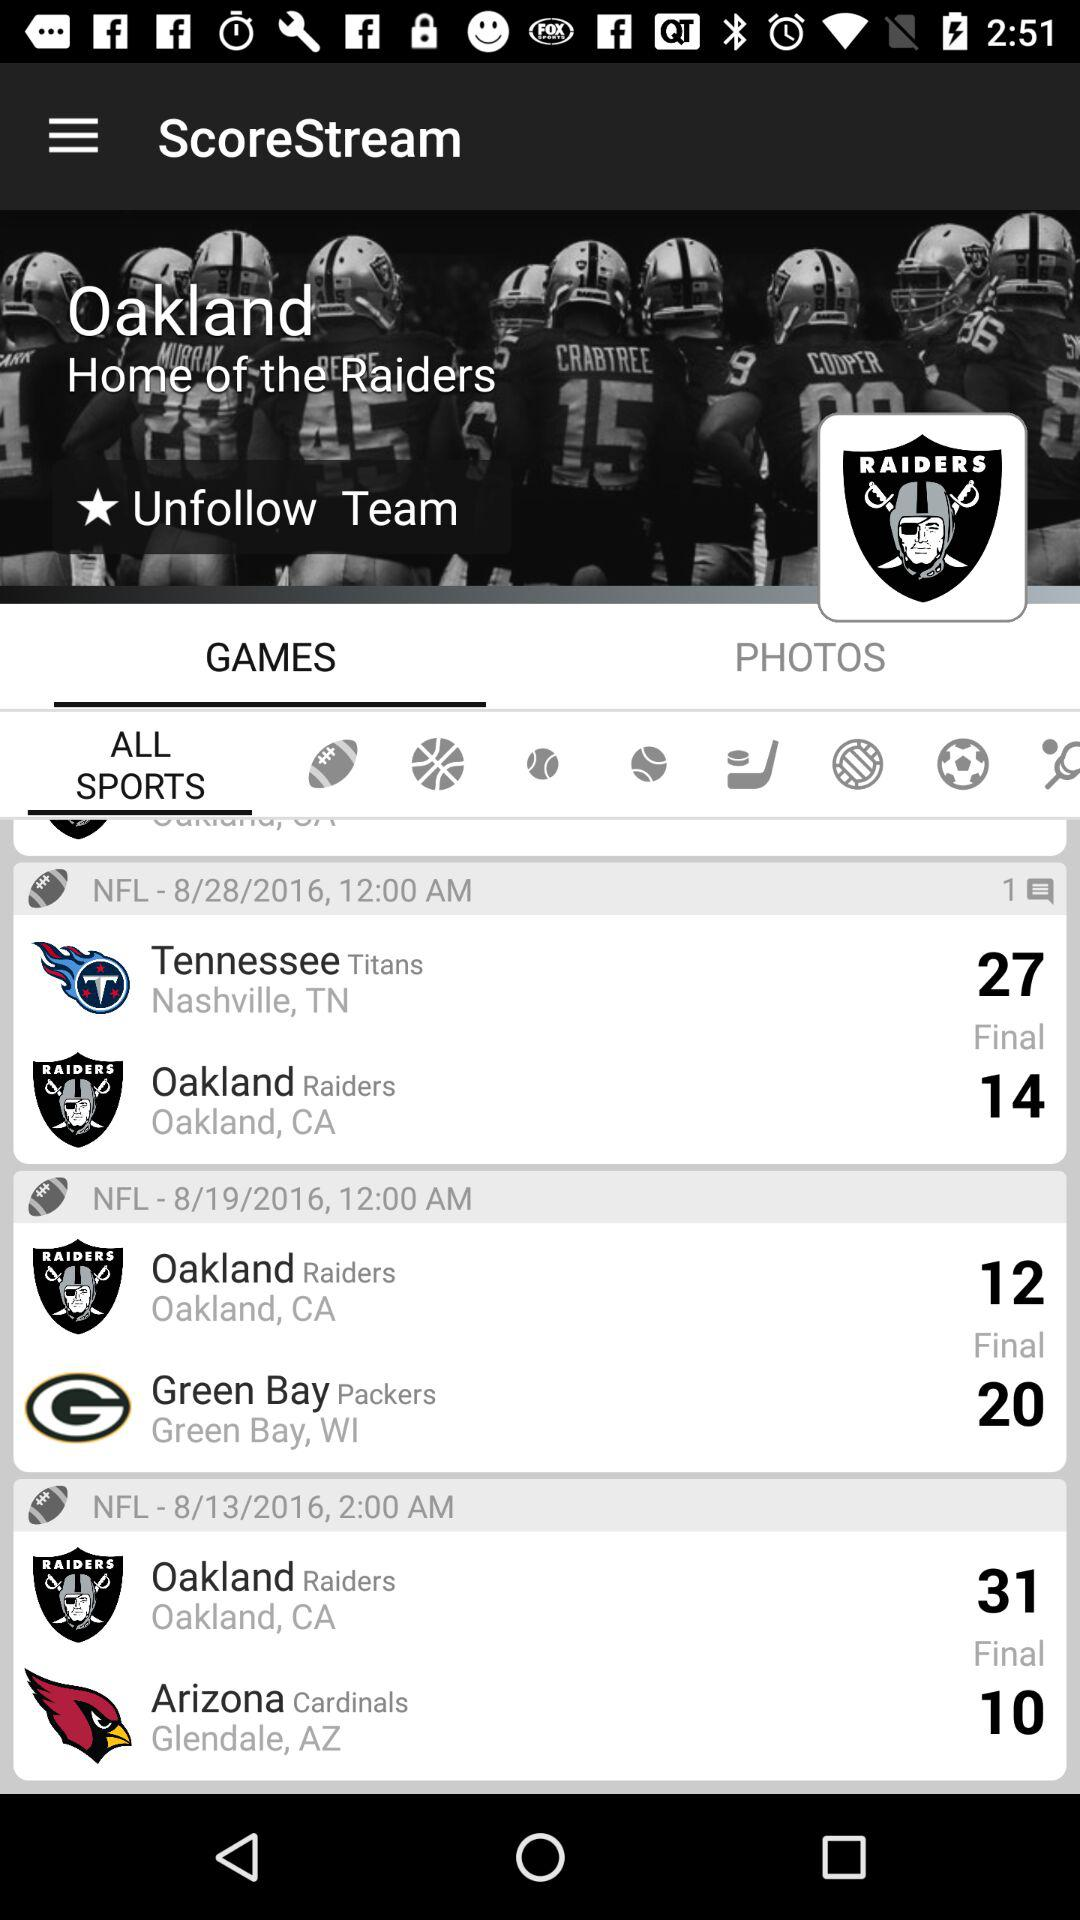How many days are there between the first and last games?
Answer the question using a single word or phrase. 15 